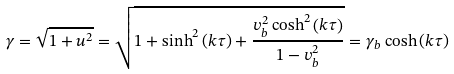Convert formula to latex. <formula><loc_0><loc_0><loc_500><loc_500>\gamma = \sqrt { 1 + { u } ^ { 2 } } = \sqrt { 1 + \sinh ^ { 2 } \left ( { k \tau } \right ) + \frac { { v _ { b } ^ { 2 } \cosh ^ { 2 } \left ( { k \tau } \right ) } } { 1 - v _ { b } ^ { 2 } } } = \gamma _ { b } \cosh \left ( { k \tau } \right )</formula> 